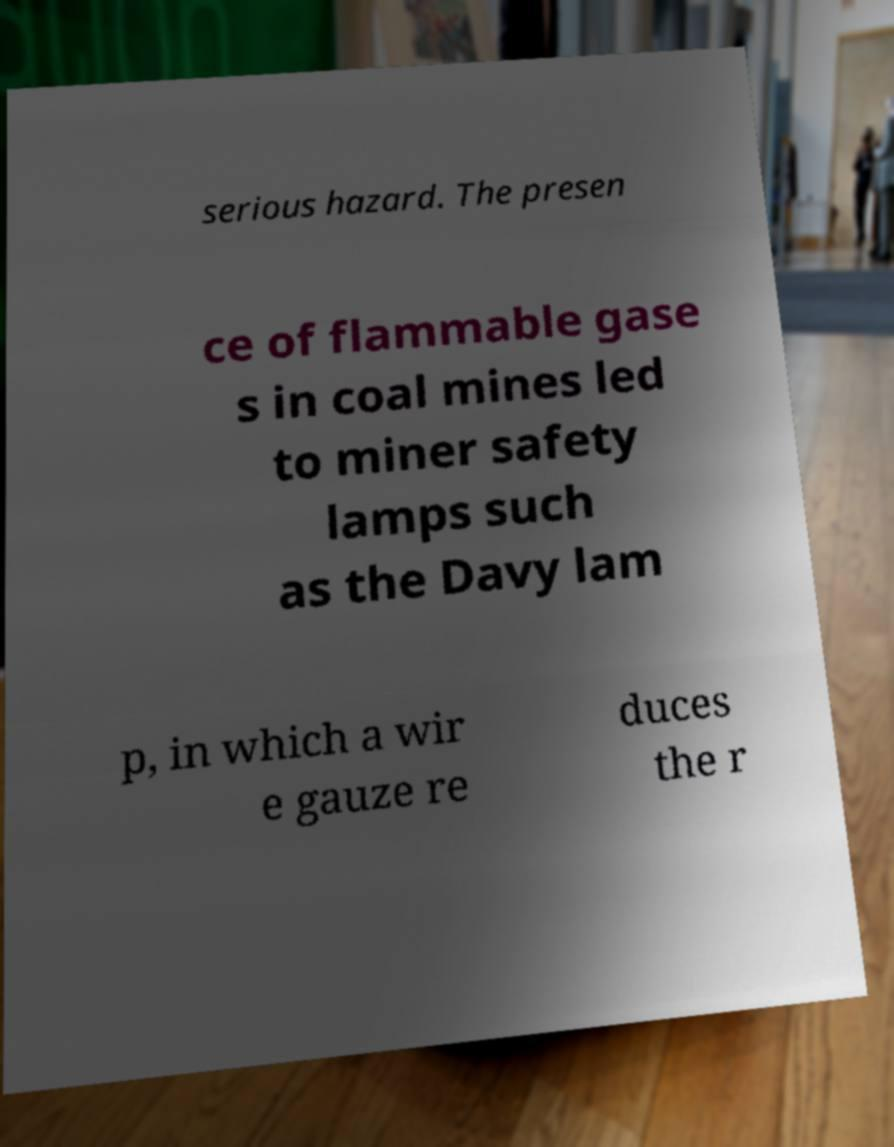Please read and relay the text visible in this image. What does it say? serious hazard. The presen ce of flammable gase s in coal mines led to miner safety lamps such as the Davy lam p, in which a wir e gauze re duces the r 